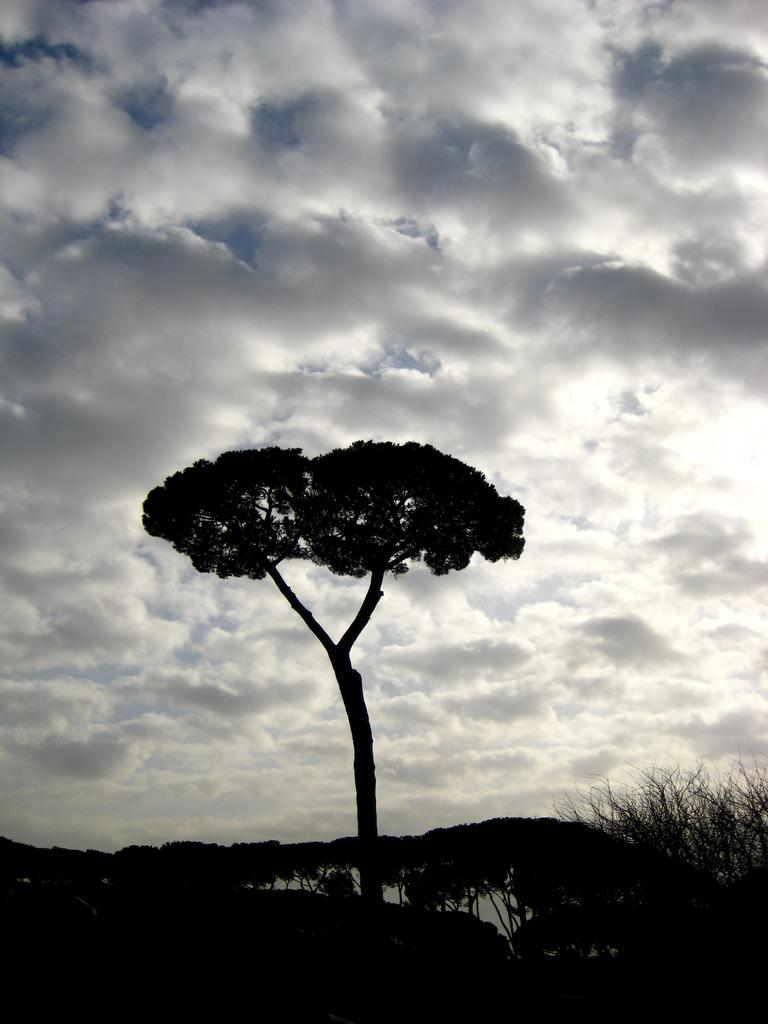What is the main subject in the middle of the image? There is a tree in the middle of the image. What can be seen at the bottom of the image? There are many plants at the bottom of the image. What is visible in the image besides the plants and tree? Water is visible in the image. What is visible at the top of the image? The sky is visible at the top of the image. What can be observed in the sky? Clouds are present in the sky. What type of jewel can be seen hanging from the tree in the image? There is no jewel present in the image; it features a tree, plants, water, and a sky with clouds. 